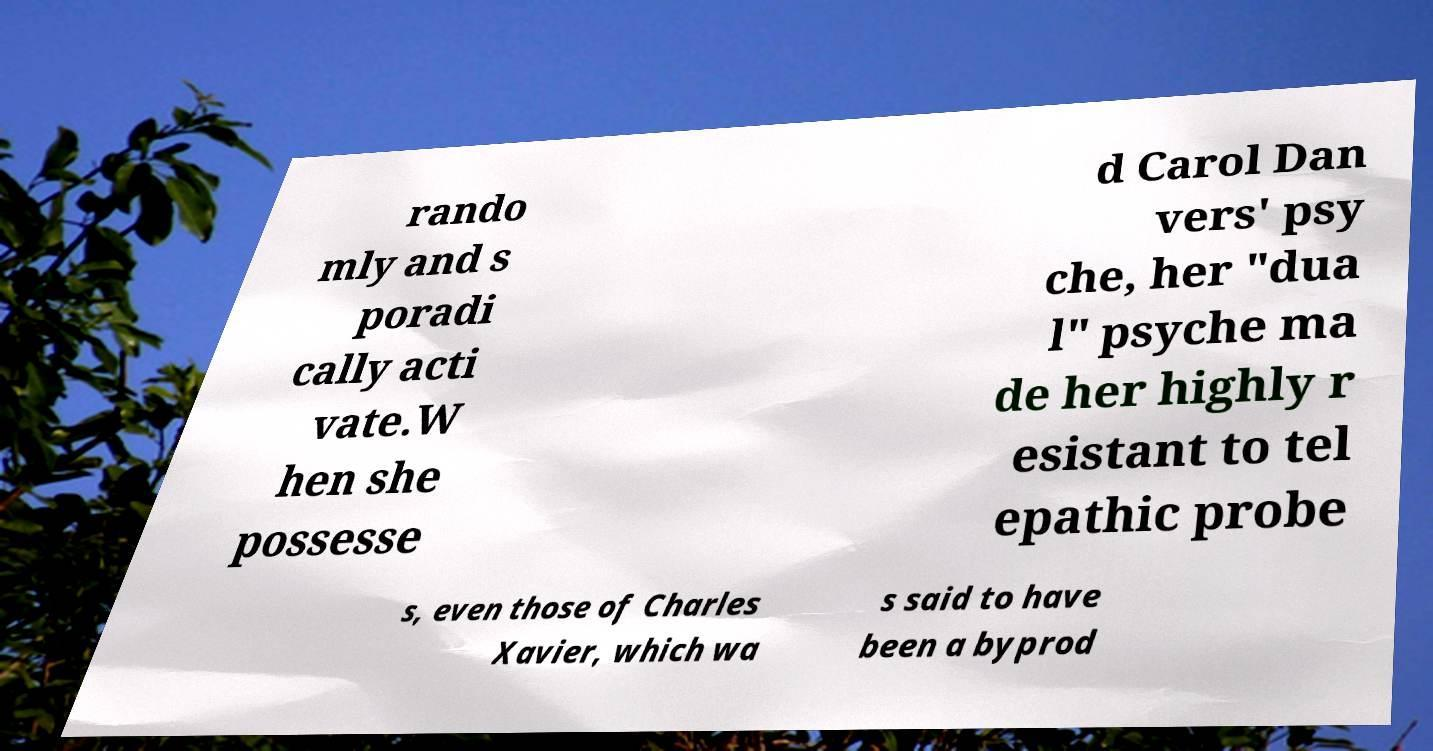There's text embedded in this image that I need extracted. Can you transcribe it verbatim? rando mly and s poradi cally acti vate.W hen she possesse d Carol Dan vers' psy che, her "dua l" psyche ma de her highly r esistant to tel epathic probe s, even those of Charles Xavier, which wa s said to have been a byprod 